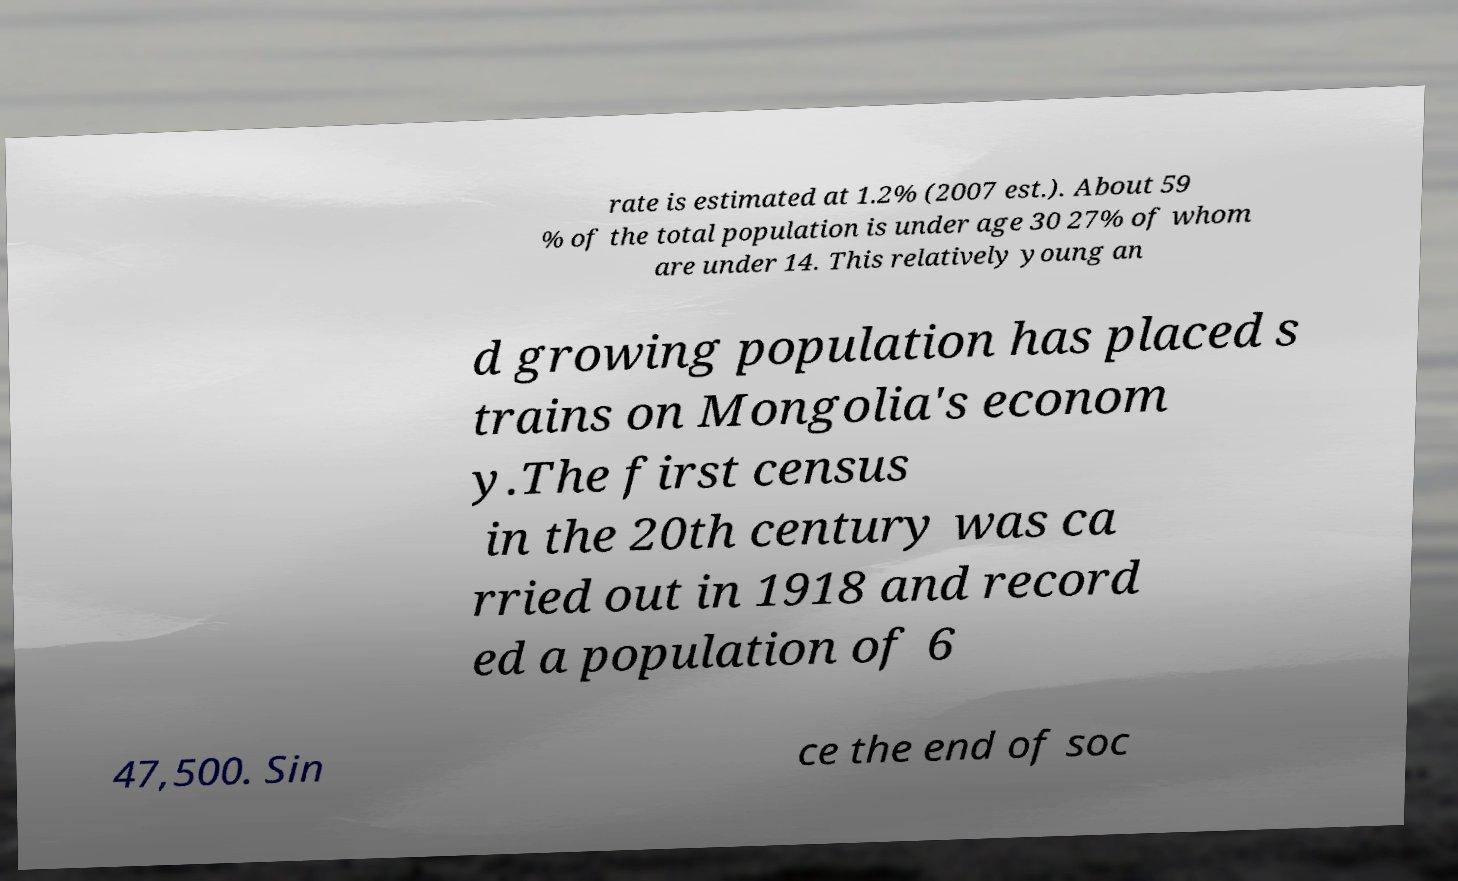I need the written content from this picture converted into text. Can you do that? rate is estimated at 1.2% (2007 est.). About 59 % of the total population is under age 30 27% of whom are under 14. This relatively young an d growing population has placed s trains on Mongolia's econom y.The first census in the 20th century was ca rried out in 1918 and record ed a population of 6 47,500. Sin ce the end of soc 